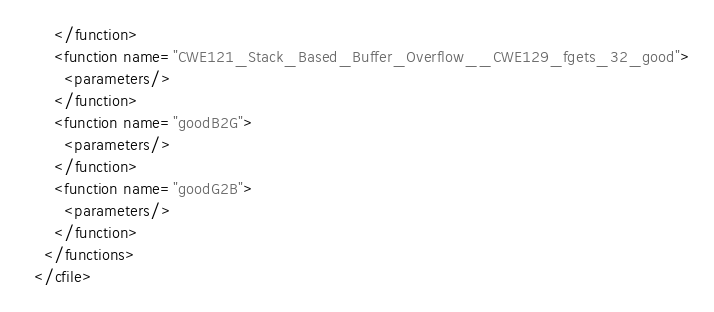Convert code to text. <code><loc_0><loc_0><loc_500><loc_500><_XML_>      </function>
      <function name="CWE121_Stack_Based_Buffer_Overflow__CWE129_fgets_32_good">
        <parameters/>
      </function>
      <function name="goodB2G">
        <parameters/>
      </function>
      <function name="goodG2B">
        <parameters/>
      </function>
    </functions>
  </cfile></code> 